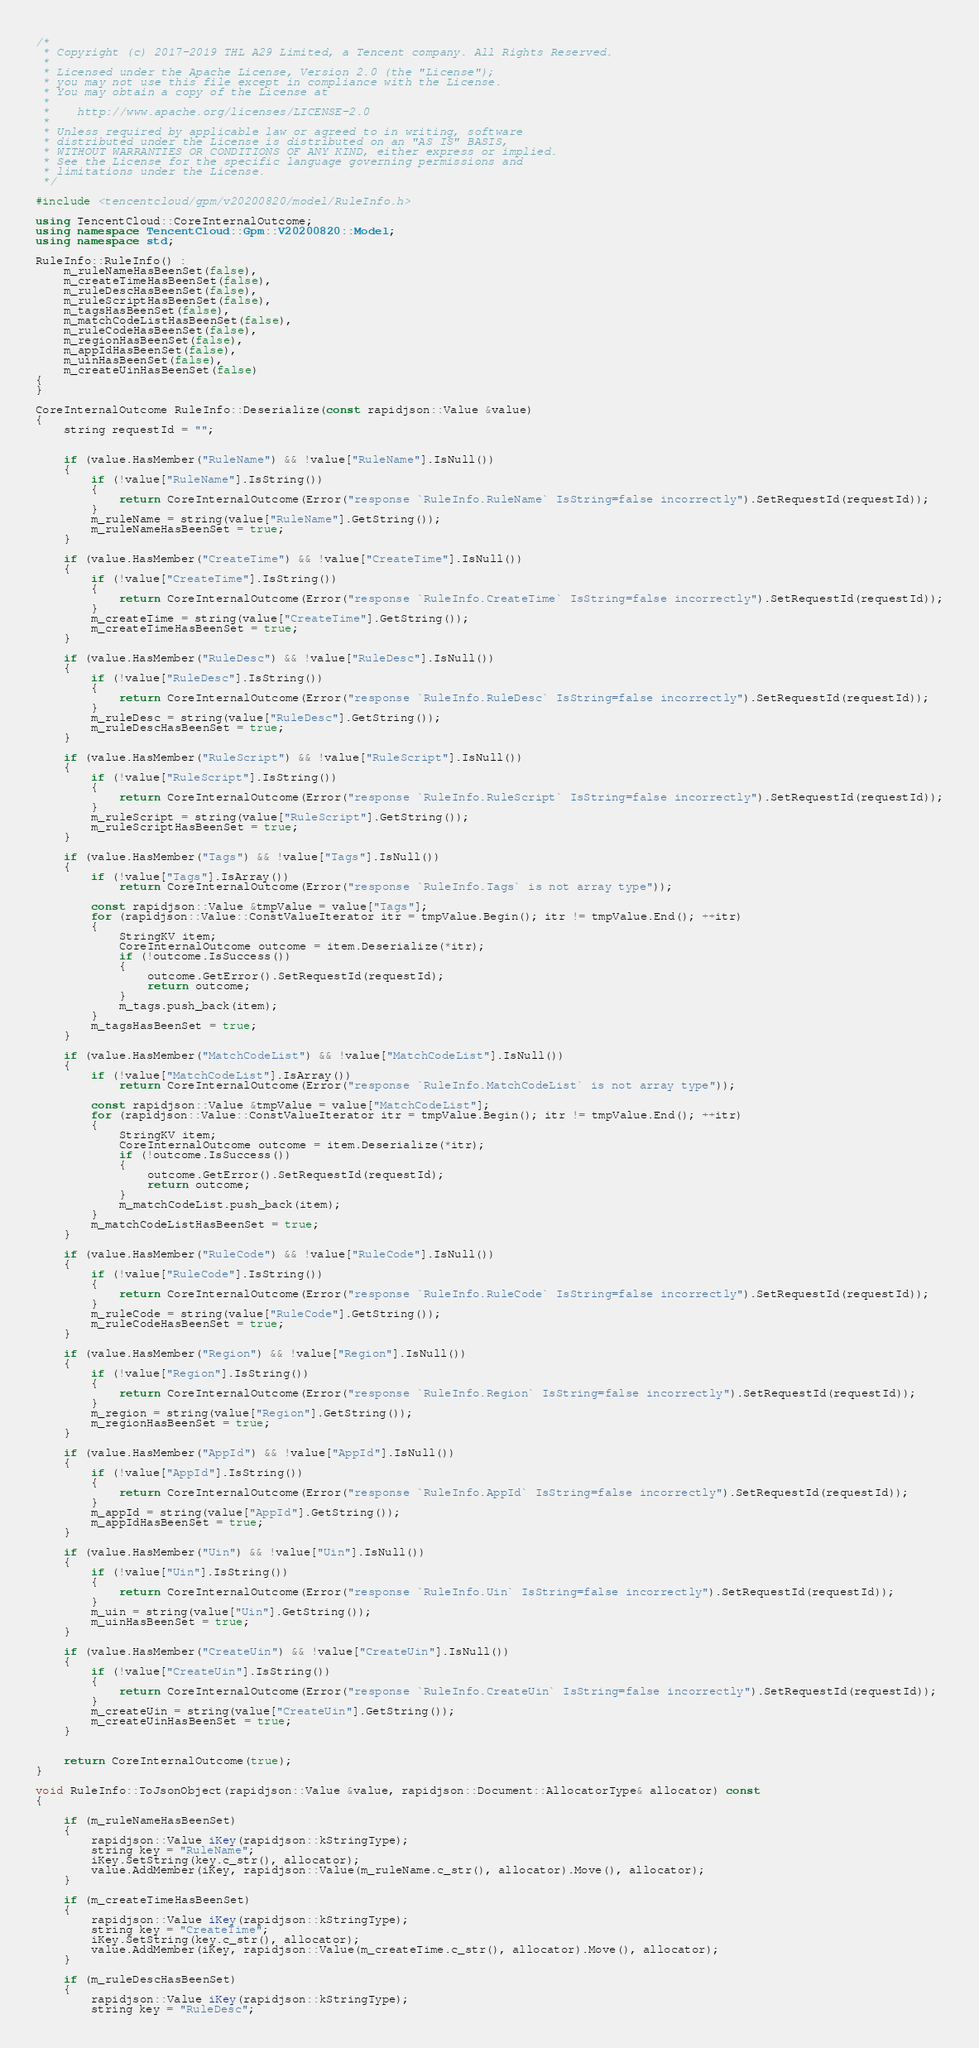<code> <loc_0><loc_0><loc_500><loc_500><_C++_>/*
 * Copyright (c) 2017-2019 THL A29 Limited, a Tencent company. All Rights Reserved.
 *
 * Licensed under the Apache License, Version 2.0 (the "License");
 * you may not use this file except in compliance with the License.
 * You may obtain a copy of the License at
 *
 *    http://www.apache.org/licenses/LICENSE-2.0
 *
 * Unless required by applicable law or agreed to in writing, software
 * distributed under the License is distributed on an "AS IS" BASIS,
 * WITHOUT WARRANTIES OR CONDITIONS OF ANY KIND, either express or implied.
 * See the License for the specific language governing permissions and
 * limitations under the License.
 */

#include <tencentcloud/gpm/v20200820/model/RuleInfo.h>

using TencentCloud::CoreInternalOutcome;
using namespace TencentCloud::Gpm::V20200820::Model;
using namespace std;

RuleInfo::RuleInfo() :
    m_ruleNameHasBeenSet(false),
    m_createTimeHasBeenSet(false),
    m_ruleDescHasBeenSet(false),
    m_ruleScriptHasBeenSet(false),
    m_tagsHasBeenSet(false),
    m_matchCodeListHasBeenSet(false),
    m_ruleCodeHasBeenSet(false),
    m_regionHasBeenSet(false),
    m_appIdHasBeenSet(false),
    m_uinHasBeenSet(false),
    m_createUinHasBeenSet(false)
{
}

CoreInternalOutcome RuleInfo::Deserialize(const rapidjson::Value &value)
{
    string requestId = "";


    if (value.HasMember("RuleName") && !value["RuleName"].IsNull())
    {
        if (!value["RuleName"].IsString())
        {
            return CoreInternalOutcome(Error("response `RuleInfo.RuleName` IsString=false incorrectly").SetRequestId(requestId));
        }
        m_ruleName = string(value["RuleName"].GetString());
        m_ruleNameHasBeenSet = true;
    }

    if (value.HasMember("CreateTime") && !value["CreateTime"].IsNull())
    {
        if (!value["CreateTime"].IsString())
        {
            return CoreInternalOutcome(Error("response `RuleInfo.CreateTime` IsString=false incorrectly").SetRequestId(requestId));
        }
        m_createTime = string(value["CreateTime"].GetString());
        m_createTimeHasBeenSet = true;
    }

    if (value.HasMember("RuleDesc") && !value["RuleDesc"].IsNull())
    {
        if (!value["RuleDesc"].IsString())
        {
            return CoreInternalOutcome(Error("response `RuleInfo.RuleDesc` IsString=false incorrectly").SetRequestId(requestId));
        }
        m_ruleDesc = string(value["RuleDesc"].GetString());
        m_ruleDescHasBeenSet = true;
    }

    if (value.HasMember("RuleScript") && !value["RuleScript"].IsNull())
    {
        if (!value["RuleScript"].IsString())
        {
            return CoreInternalOutcome(Error("response `RuleInfo.RuleScript` IsString=false incorrectly").SetRequestId(requestId));
        }
        m_ruleScript = string(value["RuleScript"].GetString());
        m_ruleScriptHasBeenSet = true;
    }

    if (value.HasMember("Tags") && !value["Tags"].IsNull())
    {
        if (!value["Tags"].IsArray())
            return CoreInternalOutcome(Error("response `RuleInfo.Tags` is not array type"));

        const rapidjson::Value &tmpValue = value["Tags"];
        for (rapidjson::Value::ConstValueIterator itr = tmpValue.Begin(); itr != tmpValue.End(); ++itr)
        {
            StringKV item;
            CoreInternalOutcome outcome = item.Deserialize(*itr);
            if (!outcome.IsSuccess())
            {
                outcome.GetError().SetRequestId(requestId);
                return outcome;
            }
            m_tags.push_back(item);
        }
        m_tagsHasBeenSet = true;
    }

    if (value.HasMember("MatchCodeList") && !value["MatchCodeList"].IsNull())
    {
        if (!value["MatchCodeList"].IsArray())
            return CoreInternalOutcome(Error("response `RuleInfo.MatchCodeList` is not array type"));

        const rapidjson::Value &tmpValue = value["MatchCodeList"];
        for (rapidjson::Value::ConstValueIterator itr = tmpValue.Begin(); itr != tmpValue.End(); ++itr)
        {
            StringKV item;
            CoreInternalOutcome outcome = item.Deserialize(*itr);
            if (!outcome.IsSuccess())
            {
                outcome.GetError().SetRequestId(requestId);
                return outcome;
            }
            m_matchCodeList.push_back(item);
        }
        m_matchCodeListHasBeenSet = true;
    }

    if (value.HasMember("RuleCode") && !value["RuleCode"].IsNull())
    {
        if (!value["RuleCode"].IsString())
        {
            return CoreInternalOutcome(Error("response `RuleInfo.RuleCode` IsString=false incorrectly").SetRequestId(requestId));
        }
        m_ruleCode = string(value["RuleCode"].GetString());
        m_ruleCodeHasBeenSet = true;
    }

    if (value.HasMember("Region") && !value["Region"].IsNull())
    {
        if (!value["Region"].IsString())
        {
            return CoreInternalOutcome(Error("response `RuleInfo.Region` IsString=false incorrectly").SetRequestId(requestId));
        }
        m_region = string(value["Region"].GetString());
        m_regionHasBeenSet = true;
    }

    if (value.HasMember("AppId") && !value["AppId"].IsNull())
    {
        if (!value["AppId"].IsString())
        {
            return CoreInternalOutcome(Error("response `RuleInfo.AppId` IsString=false incorrectly").SetRequestId(requestId));
        }
        m_appId = string(value["AppId"].GetString());
        m_appIdHasBeenSet = true;
    }

    if (value.HasMember("Uin") && !value["Uin"].IsNull())
    {
        if (!value["Uin"].IsString())
        {
            return CoreInternalOutcome(Error("response `RuleInfo.Uin` IsString=false incorrectly").SetRequestId(requestId));
        }
        m_uin = string(value["Uin"].GetString());
        m_uinHasBeenSet = true;
    }

    if (value.HasMember("CreateUin") && !value["CreateUin"].IsNull())
    {
        if (!value["CreateUin"].IsString())
        {
            return CoreInternalOutcome(Error("response `RuleInfo.CreateUin` IsString=false incorrectly").SetRequestId(requestId));
        }
        m_createUin = string(value["CreateUin"].GetString());
        m_createUinHasBeenSet = true;
    }


    return CoreInternalOutcome(true);
}

void RuleInfo::ToJsonObject(rapidjson::Value &value, rapidjson::Document::AllocatorType& allocator) const
{

    if (m_ruleNameHasBeenSet)
    {
        rapidjson::Value iKey(rapidjson::kStringType);
        string key = "RuleName";
        iKey.SetString(key.c_str(), allocator);
        value.AddMember(iKey, rapidjson::Value(m_ruleName.c_str(), allocator).Move(), allocator);
    }

    if (m_createTimeHasBeenSet)
    {
        rapidjson::Value iKey(rapidjson::kStringType);
        string key = "CreateTime";
        iKey.SetString(key.c_str(), allocator);
        value.AddMember(iKey, rapidjson::Value(m_createTime.c_str(), allocator).Move(), allocator);
    }

    if (m_ruleDescHasBeenSet)
    {
        rapidjson::Value iKey(rapidjson::kStringType);
        string key = "RuleDesc";</code> 